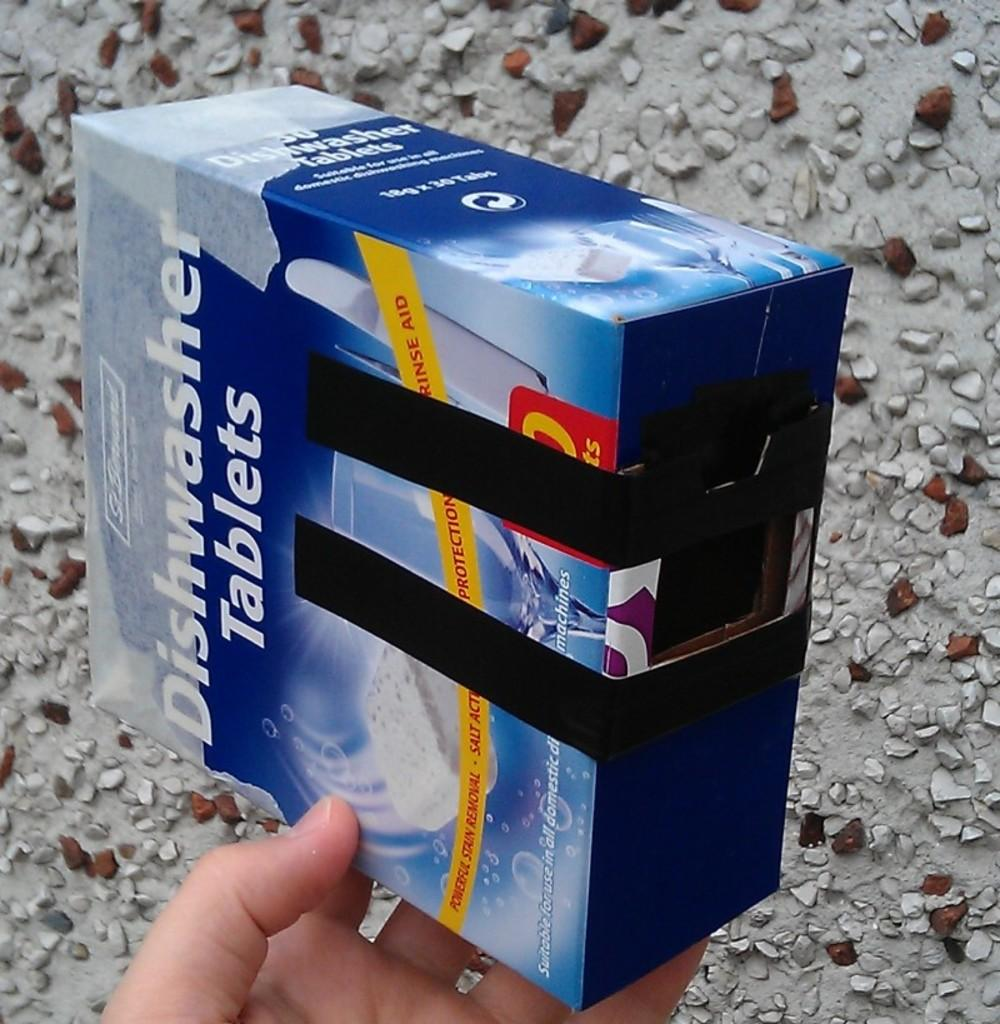Provide a one-sentence caption for the provided image. A person holding a box of diswasher tablets. 